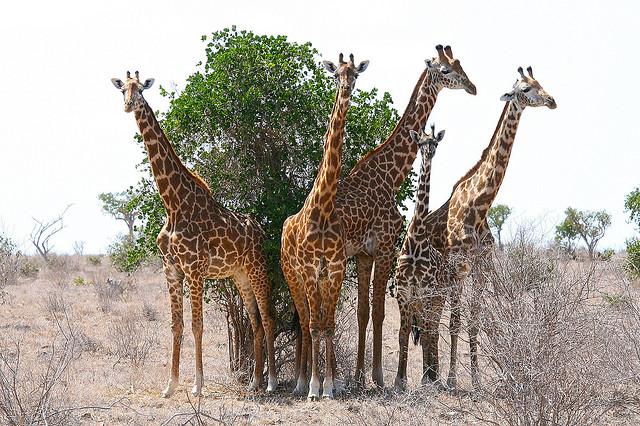Are the giraffes in the ZOO?
Concise answer only. No. How many animals are there?
Short answer required. 5. Where are the giraffes?
Write a very short answer. Outside. Are the giraffes facing us?
Concise answer only. Yes. Is this a dry place?
Write a very short answer. Yes. Are the giraffes looking at something?
Answer briefly. Yes. Is this a black and white picture?
Concise answer only. No. How many giraffes are shown?
Answer briefly. 5. What kind of tree is the giraffe under?
Give a very brief answer. Elm. What is behind the giraffes?
Keep it brief. Tree. 